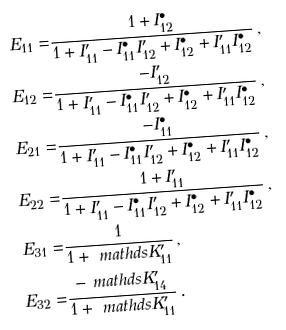<formula> <loc_0><loc_0><loc_500><loc_500>E _ { 1 1 } = & \frac { 1 + I _ { 1 2 } ^ { \bullet } } { 1 + I _ { 1 1 } ^ { \prime } - I _ { 1 1 } ^ { \bullet } I _ { 1 2 } ^ { \prime } + I _ { 1 2 } ^ { \bullet } + I _ { 1 1 } ^ { \prime } I _ { 1 2 } ^ { \bullet } } \, , \\ E _ { 1 2 } = & \frac { - I _ { 1 2 } ^ { \prime } } { 1 + I _ { 1 1 } ^ { \prime } - I _ { 1 1 } ^ { \bullet } I _ { 1 2 } ^ { \prime } + I _ { 1 2 } ^ { \bullet } + I _ { 1 1 } ^ { \prime } I _ { 1 2 } ^ { \bullet } } \, , \\ E _ { 2 1 } = & \frac { - I _ { 1 1 } ^ { \bullet } } { 1 + I _ { 1 1 } ^ { \prime } - I _ { 1 1 } ^ { \bullet } I _ { 1 2 } ^ { \prime } + I _ { 1 2 } ^ { \bullet } + I _ { 1 1 } ^ { \prime } I _ { 1 2 } ^ { \bullet } } \, , \\ E _ { 2 2 } = & \frac { 1 + I _ { 1 1 } ^ { \prime } } { 1 + I _ { 1 1 } ^ { \prime } - I _ { 1 1 } ^ { \bullet } I _ { 1 2 } ^ { \prime } + I _ { 1 2 } ^ { \bullet } + I _ { 1 1 } ^ { \prime } I _ { 1 2 } ^ { \bullet } } \, , \\ E _ { 3 1 } = & \frac { 1 } { 1 + \ m a t h d s { K } _ { 1 1 } ^ { \prime } } \, , \\ E _ { 3 2 } = & \frac { - \ m a t h d s { K } _ { 1 4 } ^ { \prime } } { 1 + \ m a t h d s { K } _ { 1 1 } ^ { \prime } } \, .</formula> 